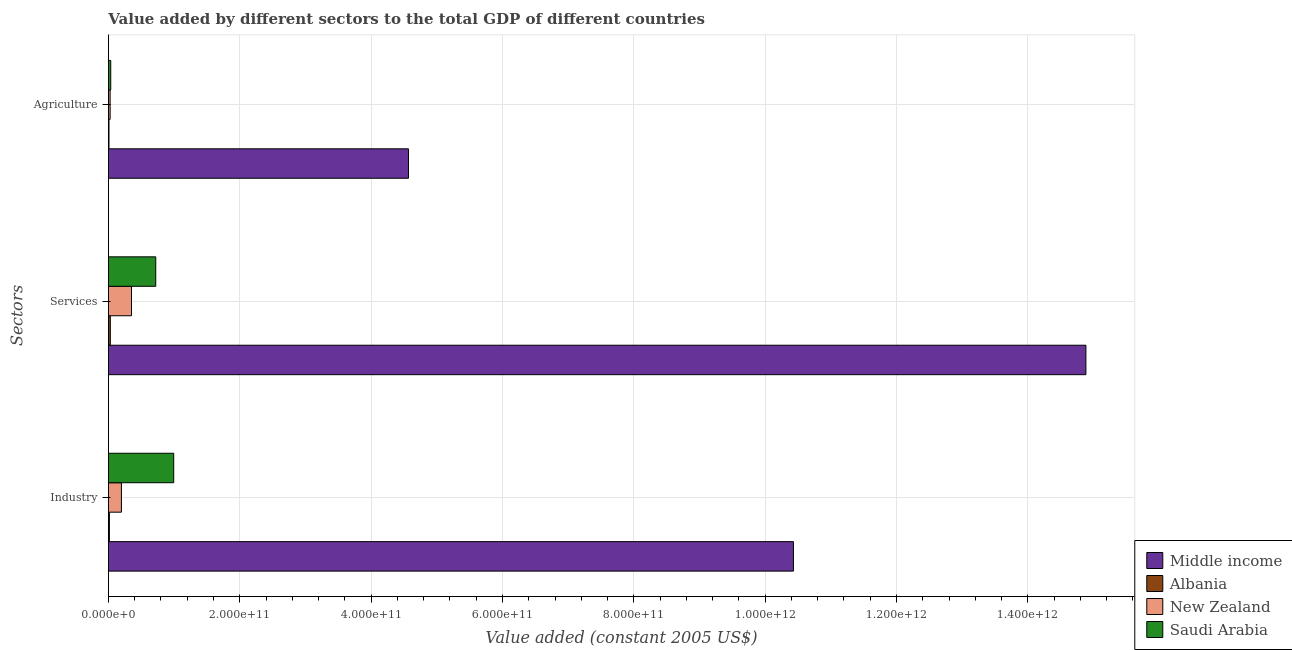How many different coloured bars are there?
Provide a short and direct response. 4. How many bars are there on the 1st tick from the top?
Give a very brief answer. 4. What is the label of the 3rd group of bars from the top?
Keep it short and to the point. Industry. What is the value added by services in Saudi Arabia?
Ensure brevity in your answer.  7.21e+1. Across all countries, what is the maximum value added by services?
Offer a very short reply. 1.49e+12. Across all countries, what is the minimum value added by services?
Make the answer very short. 2.87e+09. In which country was the value added by industrial sector minimum?
Your answer should be compact. Albania. What is the total value added by industrial sector in the graph?
Offer a very short reply. 1.16e+12. What is the difference between the value added by services in Albania and that in Saudi Arabia?
Keep it short and to the point. -6.92e+1. What is the difference between the value added by services in Albania and the value added by agricultural sector in New Zealand?
Your response must be concise. 2.91e+08. What is the average value added by agricultural sector per country?
Give a very brief answer. 1.16e+11. What is the difference between the value added by services and value added by agricultural sector in New Zealand?
Offer a terse response. 3.25e+1. In how many countries, is the value added by services greater than 1040000000000 US$?
Make the answer very short. 1. What is the ratio of the value added by industrial sector in Saudi Arabia to that in Albania?
Ensure brevity in your answer.  68.3. Is the difference between the value added by agricultural sector in Middle income and New Zealand greater than the difference between the value added by industrial sector in Middle income and New Zealand?
Give a very brief answer. No. What is the difference between the highest and the second highest value added by agricultural sector?
Give a very brief answer. 4.53e+11. What is the difference between the highest and the lowest value added by services?
Give a very brief answer. 1.49e+12. Is the sum of the value added by industrial sector in New Zealand and Middle income greater than the maximum value added by services across all countries?
Give a very brief answer. No. What does the 1st bar from the top in Industry represents?
Make the answer very short. Saudi Arabia. Is it the case that in every country, the sum of the value added by industrial sector and value added by services is greater than the value added by agricultural sector?
Provide a succinct answer. Yes. How many countries are there in the graph?
Provide a short and direct response. 4. What is the difference between two consecutive major ticks on the X-axis?
Offer a terse response. 2.00e+11. Are the values on the major ticks of X-axis written in scientific E-notation?
Provide a succinct answer. Yes. Does the graph contain grids?
Offer a terse response. Yes. Where does the legend appear in the graph?
Your response must be concise. Bottom right. What is the title of the graph?
Keep it short and to the point. Value added by different sectors to the total GDP of different countries. Does "Greece" appear as one of the legend labels in the graph?
Make the answer very short. No. What is the label or title of the X-axis?
Your response must be concise. Value added (constant 2005 US$). What is the label or title of the Y-axis?
Your response must be concise. Sectors. What is the Value added (constant 2005 US$) of Middle income in Industry?
Offer a terse response. 1.04e+12. What is the Value added (constant 2005 US$) of Albania in Industry?
Offer a terse response. 1.46e+09. What is the Value added (constant 2005 US$) in New Zealand in Industry?
Your response must be concise. 1.98e+1. What is the Value added (constant 2005 US$) of Saudi Arabia in Industry?
Keep it short and to the point. 9.94e+1. What is the Value added (constant 2005 US$) of Middle income in Services?
Keep it short and to the point. 1.49e+12. What is the Value added (constant 2005 US$) of Albania in Services?
Your answer should be very brief. 2.87e+09. What is the Value added (constant 2005 US$) in New Zealand in Services?
Your answer should be very brief. 3.51e+1. What is the Value added (constant 2005 US$) in Saudi Arabia in Services?
Offer a terse response. 7.21e+1. What is the Value added (constant 2005 US$) in Middle income in Agriculture?
Your answer should be compact. 4.57e+11. What is the Value added (constant 2005 US$) of Albania in Agriculture?
Keep it short and to the point. 8.69e+08. What is the Value added (constant 2005 US$) of New Zealand in Agriculture?
Provide a short and direct response. 2.58e+09. What is the Value added (constant 2005 US$) of Saudi Arabia in Agriculture?
Offer a very short reply. 3.50e+09. Across all Sectors, what is the maximum Value added (constant 2005 US$) of Middle income?
Provide a short and direct response. 1.49e+12. Across all Sectors, what is the maximum Value added (constant 2005 US$) in Albania?
Provide a succinct answer. 2.87e+09. Across all Sectors, what is the maximum Value added (constant 2005 US$) of New Zealand?
Offer a very short reply. 3.51e+1. Across all Sectors, what is the maximum Value added (constant 2005 US$) in Saudi Arabia?
Provide a succinct answer. 9.94e+1. Across all Sectors, what is the minimum Value added (constant 2005 US$) in Middle income?
Provide a short and direct response. 4.57e+11. Across all Sectors, what is the minimum Value added (constant 2005 US$) in Albania?
Give a very brief answer. 8.69e+08. Across all Sectors, what is the minimum Value added (constant 2005 US$) of New Zealand?
Your response must be concise. 2.58e+09. Across all Sectors, what is the minimum Value added (constant 2005 US$) of Saudi Arabia?
Make the answer very short. 3.50e+09. What is the total Value added (constant 2005 US$) in Middle income in the graph?
Give a very brief answer. 2.99e+12. What is the total Value added (constant 2005 US$) of Albania in the graph?
Provide a succinct answer. 5.20e+09. What is the total Value added (constant 2005 US$) of New Zealand in the graph?
Ensure brevity in your answer.  5.75e+1. What is the total Value added (constant 2005 US$) in Saudi Arabia in the graph?
Your response must be concise. 1.75e+11. What is the difference between the Value added (constant 2005 US$) in Middle income in Industry and that in Services?
Provide a short and direct response. -4.45e+11. What is the difference between the Value added (constant 2005 US$) of Albania in Industry and that in Services?
Ensure brevity in your answer.  -1.42e+09. What is the difference between the Value added (constant 2005 US$) of New Zealand in Industry and that in Services?
Keep it short and to the point. -1.53e+1. What is the difference between the Value added (constant 2005 US$) of Saudi Arabia in Industry and that in Services?
Your response must be concise. 2.73e+1. What is the difference between the Value added (constant 2005 US$) of Middle income in Industry and that in Agriculture?
Give a very brief answer. 5.86e+11. What is the difference between the Value added (constant 2005 US$) in Albania in Industry and that in Agriculture?
Provide a short and direct response. 5.86e+08. What is the difference between the Value added (constant 2005 US$) of New Zealand in Industry and that in Agriculture?
Offer a very short reply. 1.72e+1. What is the difference between the Value added (constant 2005 US$) in Saudi Arabia in Industry and that in Agriculture?
Ensure brevity in your answer.  9.59e+1. What is the difference between the Value added (constant 2005 US$) in Middle income in Services and that in Agriculture?
Keep it short and to the point. 1.03e+12. What is the difference between the Value added (constant 2005 US$) of Albania in Services and that in Agriculture?
Offer a terse response. 2.00e+09. What is the difference between the Value added (constant 2005 US$) in New Zealand in Services and that in Agriculture?
Your answer should be compact. 3.25e+1. What is the difference between the Value added (constant 2005 US$) of Saudi Arabia in Services and that in Agriculture?
Provide a short and direct response. 6.86e+1. What is the difference between the Value added (constant 2005 US$) in Middle income in Industry and the Value added (constant 2005 US$) in Albania in Services?
Keep it short and to the point. 1.04e+12. What is the difference between the Value added (constant 2005 US$) of Middle income in Industry and the Value added (constant 2005 US$) of New Zealand in Services?
Keep it short and to the point. 1.01e+12. What is the difference between the Value added (constant 2005 US$) of Middle income in Industry and the Value added (constant 2005 US$) of Saudi Arabia in Services?
Give a very brief answer. 9.71e+11. What is the difference between the Value added (constant 2005 US$) of Albania in Industry and the Value added (constant 2005 US$) of New Zealand in Services?
Ensure brevity in your answer.  -3.37e+1. What is the difference between the Value added (constant 2005 US$) of Albania in Industry and the Value added (constant 2005 US$) of Saudi Arabia in Services?
Ensure brevity in your answer.  -7.06e+1. What is the difference between the Value added (constant 2005 US$) of New Zealand in Industry and the Value added (constant 2005 US$) of Saudi Arabia in Services?
Offer a very short reply. -5.23e+1. What is the difference between the Value added (constant 2005 US$) in Middle income in Industry and the Value added (constant 2005 US$) in Albania in Agriculture?
Give a very brief answer. 1.04e+12. What is the difference between the Value added (constant 2005 US$) in Middle income in Industry and the Value added (constant 2005 US$) in New Zealand in Agriculture?
Your answer should be compact. 1.04e+12. What is the difference between the Value added (constant 2005 US$) in Middle income in Industry and the Value added (constant 2005 US$) in Saudi Arabia in Agriculture?
Your response must be concise. 1.04e+12. What is the difference between the Value added (constant 2005 US$) in Albania in Industry and the Value added (constant 2005 US$) in New Zealand in Agriculture?
Your answer should be compact. -1.13e+09. What is the difference between the Value added (constant 2005 US$) of Albania in Industry and the Value added (constant 2005 US$) of Saudi Arabia in Agriculture?
Provide a succinct answer. -2.05e+09. What is the difference between the Value added (constant 2005 US$) of New Zealand in Industry and the Value added (constant 2005 US$) of Saudi Arabia in Agriculture?
Ensure brevity in your answer.  1.63e+1. What is the difference between the Value added (constant 2005 US$) of Middle income in Services and the Value added (constant 2005 US$) of Albania in Agriculture?
Provide a short and direct response. 1.49e+12. What is the difference between the Value added (constant 2005 US$) in Middle income in Services and the Value added (constant 2005 US$) in New Zealand in Agriculture?
Provide a succinct answer. 1.49e+12. What is the difference between the Value added (constant 2005 US$) of Middle income in Services and the Value added (constant 2005 US$) of Saudi Arabia in Agriculture?
Offer a terse response. 1.48e+12. What is the difference between the Value added (constant 2005 US$) in Albania in Services and the Value added (constant 2005 US$) in New Zealand in Agriculture?
Provide a succinct answer. 2.91e+08. What is the difference between the Value added (constant 2005 US$) of Albania in Services and the Value added (constant 2005 US$) of Saudi Arabia in Agriculture?
Provide a succinct answer. -6.28e+08. What is the difference between the Value added (constant 2005 US$) of New Zealand in Services and the Value added (constant 2005 US$) of Saudi Arabia in Agriculture?
Offer a terse response. 3.16e+1. What is the average Value added (constant 2005 US$) of Middle income per Sectors?
Make the answer very short. 9.96e+11. What is the average Value added (constant 2005 US$) of Albania per Sectors?
Offer a very short reply. 1.73e+09. What is the average Value added (constant 2005 US$) in New Zealand per Sectors?
Offer a very short reply. 1.92e+1. What is the average Value added (constant 2005 US$) in Saudi Arabia per Sectors?
Your answer should be very brief. 5.83e+1. What is the difference between the Value added (constant 2005 US$) in Middle income and Value added (constant 2005 US$) in Albania in Industry?
Your response must be concise. 1.04e+12. What is the difference between the Value added (constant 2005 US$) of Middle income and Value added (constant 2005 US$) of New Zealand in Industry?
Offer a terse response. 1.02e+12. What is the difference between the Value added (constant 2005 US$) of Middle income and Value added (constant 2005 US$) of Saudi Arabia in Industry?
Give a very brief answer. 9.44e+11. What is the difference between the Value added (constant 2005 US$) of Albania and Value added (constant 2005 US$) of New Zealand in Industry?
Provide a succinct answer. -1.83e+1. What is the difference between the Value added (constant 2005 US$) of Albania and Value added (constant 2005 US$) of Saudi Arabia in Industry?
Provide a short and direct response. -9.79e+1. What is the difference between the Value added (constant 2005 US$) in New Zealand and Value added (constant 2005 US$) in Saudi Arabia in Industry?
Offer a terse response. -7.96e+1. What is the difference between the Value added (constant 2005 US$) in Middle income and Value added (constant 2005 US$) in Albania in Services?
Keep it short and to the point. 1.49e+12. What is the difference between the Value added (constant 2005 US$) in Middle income and Value added (constant 2005 US$) in New Zealand in Services?
Provide a short and direct response. 1.45e+12. What is the difference between the Value added (constant 2005 US$) in Middle income and Value added (constant 2005 US$) in Saudi Arabia in Services?
Ensure brevity in your answer.  1.42e+12. What is the difference between the Value added (constant 2005 US$) of Albania and Value added (constant 2005 US$) of New Zealand in Services?
Your answer should be very brief. -3.22e+1. What is the difference between the Value added (constant 2005 US$) in Albania and Value added (constant 2005 US$) in Saudi Arabia in Services?
Provide a succinct answer. -6.92e+1. What is the difference between the Value added (constant 2005 US$) of New Zealand and Value added (constant 2005 US$) of Saudi Arabia in Services?
Your answer should be compact. -3.69e+1. What is the difference between the Value added (constant 2005 US$) in Middle income and Value added (constant 2005 US$) in Albania in Agriculture?
Your response must be concise. 4.56e+11. What is the difference between the Value added (constant 2005 US$) in Middle income and Value added (constant 2005 US$) in New Zealand in Agriculture?
Your answer should be compact. 4.54e+11. What is the difference between the Value added (constant 2005 US$) of Middle income and Value added (constant 2005 US$) of Saudi Arabia in Agriculture?
Make the answer very short. 4.53e+11. What is the difference between the Value added (constant 2005 US$) of Albania and Value added (constant 2005 US$) of New Zealand in Agriculture?
Give a very brief answer. -1.71e+09. What is the difference between the Value added (constant 2005 US$) of Albania and Value added (constant 2005 US$) of Saudi Arabia in Agriculture?
Provide a short and direct response. -2.63e+09. What is the difference between the Value added (constant 2005 US$) of New Zealand and Value added (constant 2005 US$) of Saudi Arabia in Agriculture?
Your answer should be compact. -9.18e+08. What is the ratio of the Value added (constant 2005 US$) of Middle income in Industry to that in Services?
Give a very brief answer. 0.7. What is the ratio of the Value added (constant 2005 US$) in Albania in Industry to that in Services?
Your answer should be very brief. 0.51. What is the ratio of the Value added (constant 2005 US$) in New Zealand in Industry to that in Services?
Offer a terse response. 0.56. What is the ratio of the Value added (constant 2005 US$) in Saudi Arabia in Industry to that in Services?
Give a very brief answer. 1.38. What is the ratio of the Value added (constant 2005 US$) of Middle income in Industry to that in Agriculture?
Your response must be concise. 2.28. What is the ratio of the Value added (constant 2005 US$) in Albania in Industry to that in Agriculture?
Ensure brevity in your answer.  1.67. What is the ratio of the Value added (constant 2005 US$) of New Zealand in Industry to that in Agriculture?
Your response must be concise. 7.66. What is the ratio of the Value added (constant 2005 US$) of Saudi Arabia in Industry to that in Agriculture?
Your answer should be very brief. 28.38. What is the ratio of the Value added (constant 2005 US$) in Middle income in Services to that in Agriculture?
Provide a short and direct response. 3.26. What is the ratio of the Value added (constant 2005 US$) in Albania in Services to that in Agriculture?
Give a very brief answer. 3.31. What is the ratio of the Value added (constant 2005 US$) of New Zealand in Services to that in Agriculture?
Your answer should be very brief. 13.6. What is the ratio of the Value added (constant 2005 US$) in Saudi Arabia in Services to that in Agriculture?
Offer a terse response. 20.58. What is the difference between the highest and the second highest Value added (constant 2005 US$) of Middle income?
Make the answer very short. 4.45e+11. What is the difference between the highest and the second highest Value added (constant 2005 US$) in Albania?
Ensure brevity in your answer.  1.42e+09. What is the difference between the highest and the second highest Value added (constant 2005 US$) of New Zealand?
Your answer should be very brief. 1.53e+1. What is the difference between the highest and the second highest Value added (constant 2005 US$) of Saudi Arabia?
Offer a very short reply. 2.73e+1. What is the difference between the highest and the lowest Value added (constant 2005 US$) in Middle income?
Offer a terse response. 1.03e+12. What is the difference between the highest and the lowest Value added (constant 2005 US$) in Albania?
Give a very brief answer. 2.00e+09. What is the difference between the highest and the lowest Value added (constant 2005 US$) of New Zealand?
Offer a very short reply. 3.25e+1. What is the difference between the highest and the lowest Value added (constant 2005 US$) of Saudi Arabia?
Offer a very short reply. 9.59e+1. 